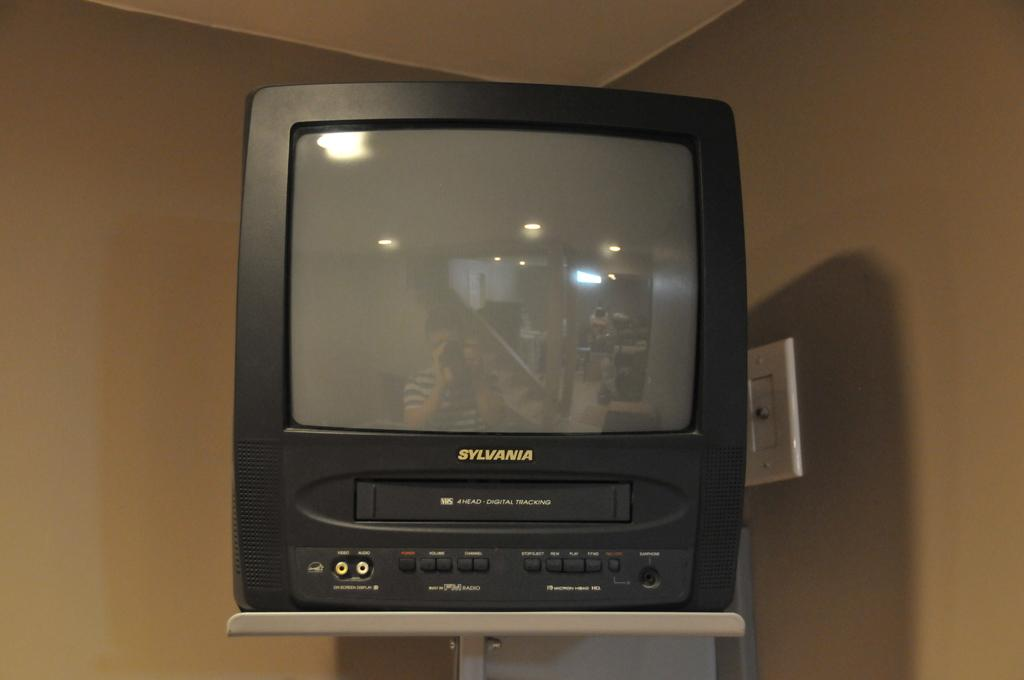Provide a one-sentence caption for the provided image. a Sylvania TV set standing on a stand. 